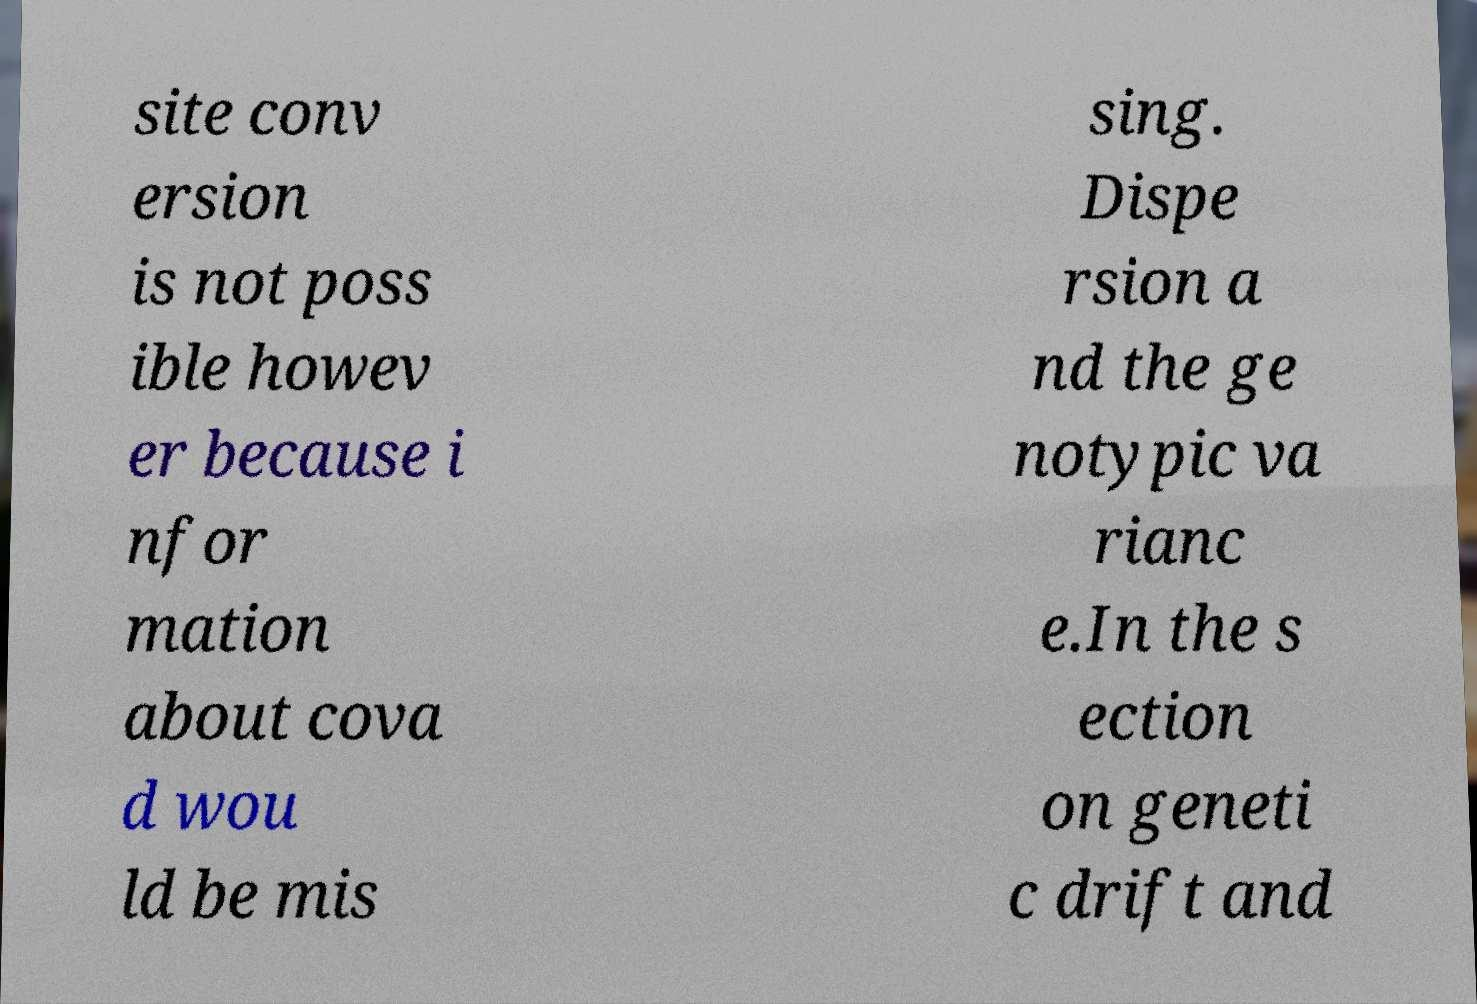There's text embedded in this image that I need extracted. Can you transcribe it verbatim? site conv ersion is not poss ible howev er because i nfor mation about cova d wou ld be mis sing. Dispe rsion a nd the ge notypic va rianc e.In the s ection on geneti c drift and 